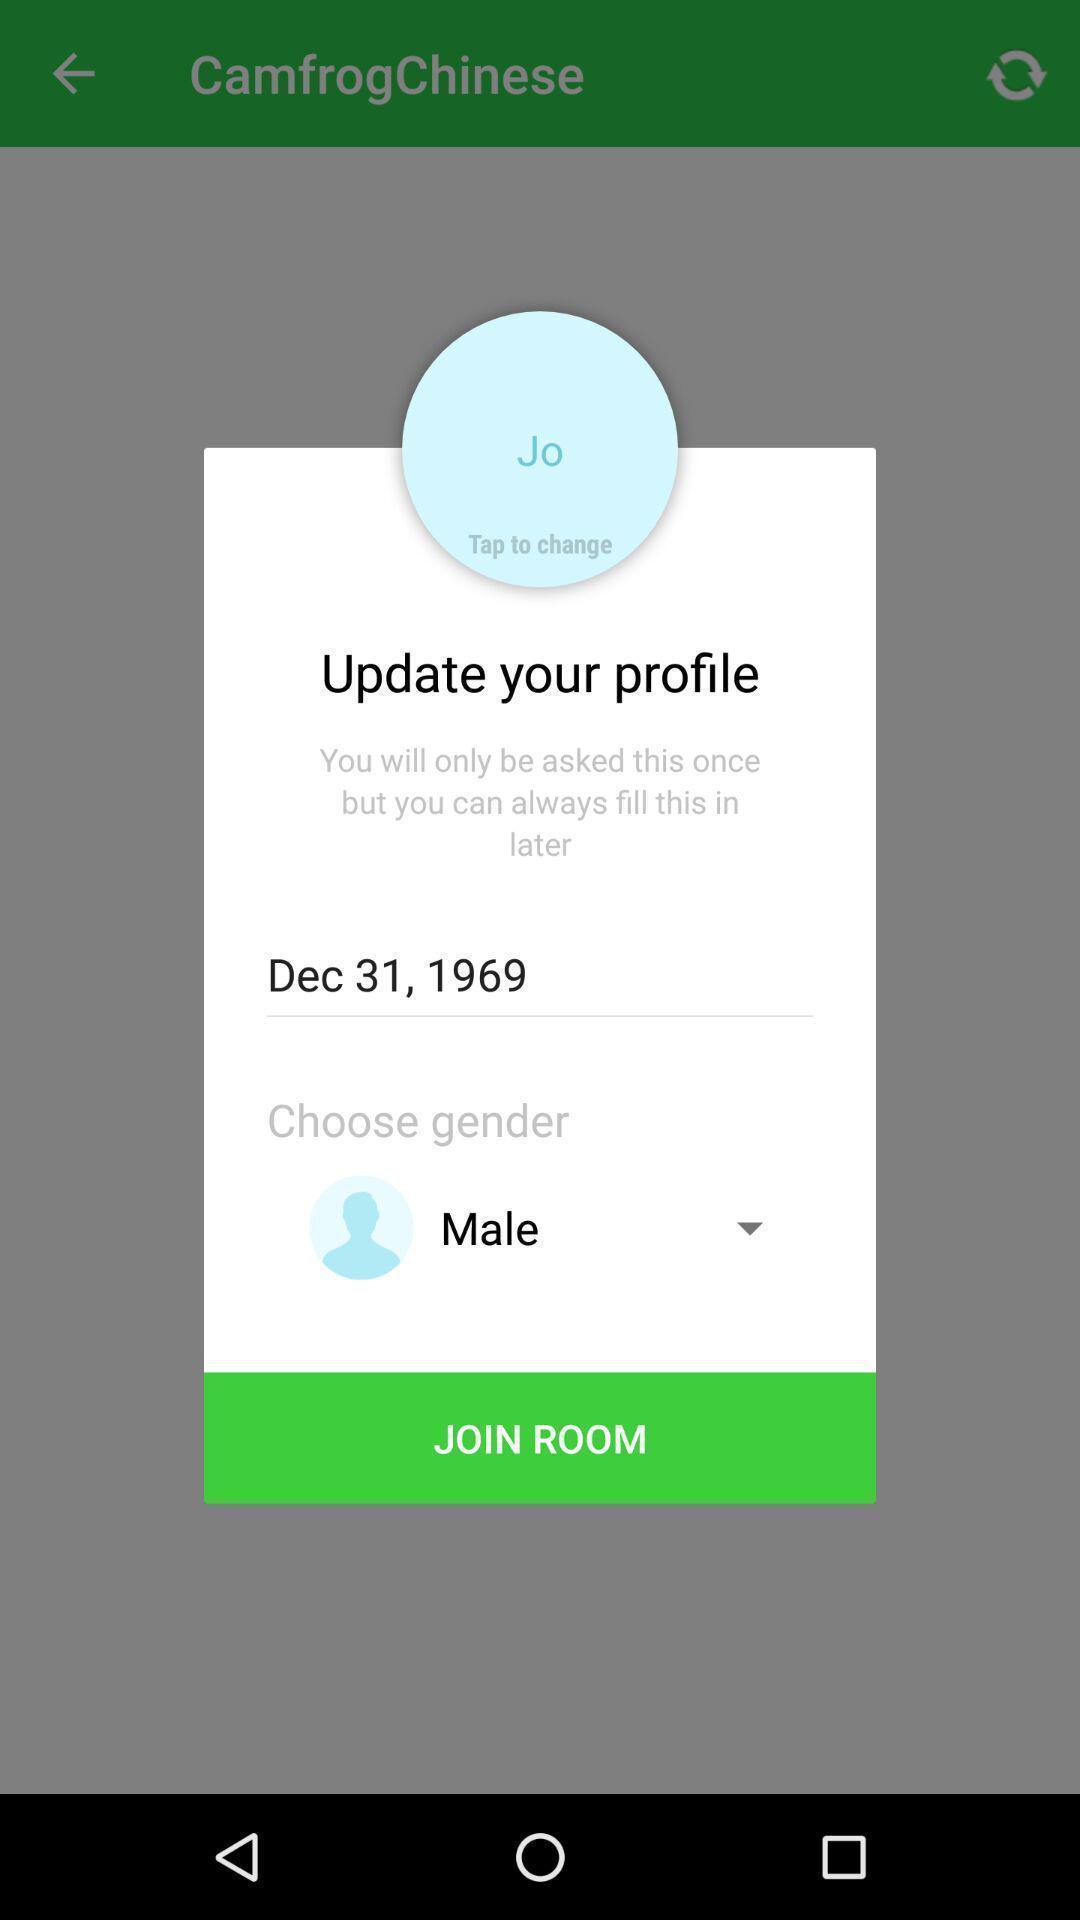Give me a narrative description of this picture. Screen shows to join room. 